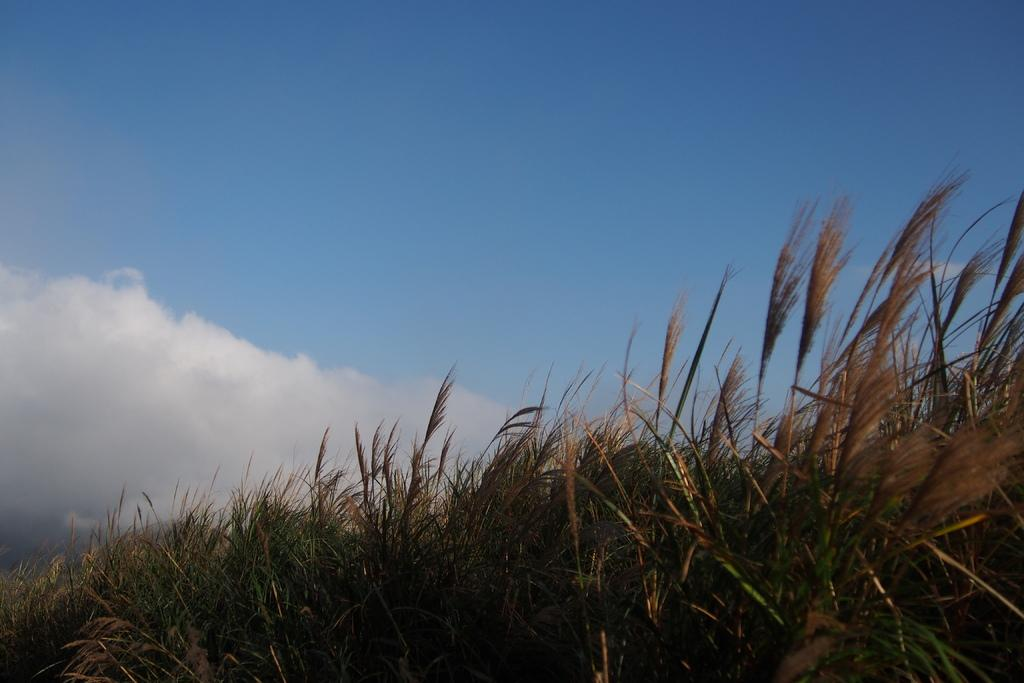What is located in the foreground of the image? There are plants in the foreground of the image. What can be seen in the background of the image? The sky is visible in the background of the image. How would you describe the sky in the image? The sky appears to be clear in the image. Can you tell me who won the fight depicted in the image? There is no fight depicted in the image; it features plants in the foreground and a clear sky in the background. What type of prose can be read in the image? There is no prose present in the image; it is a visual representation of plants and the sky. 